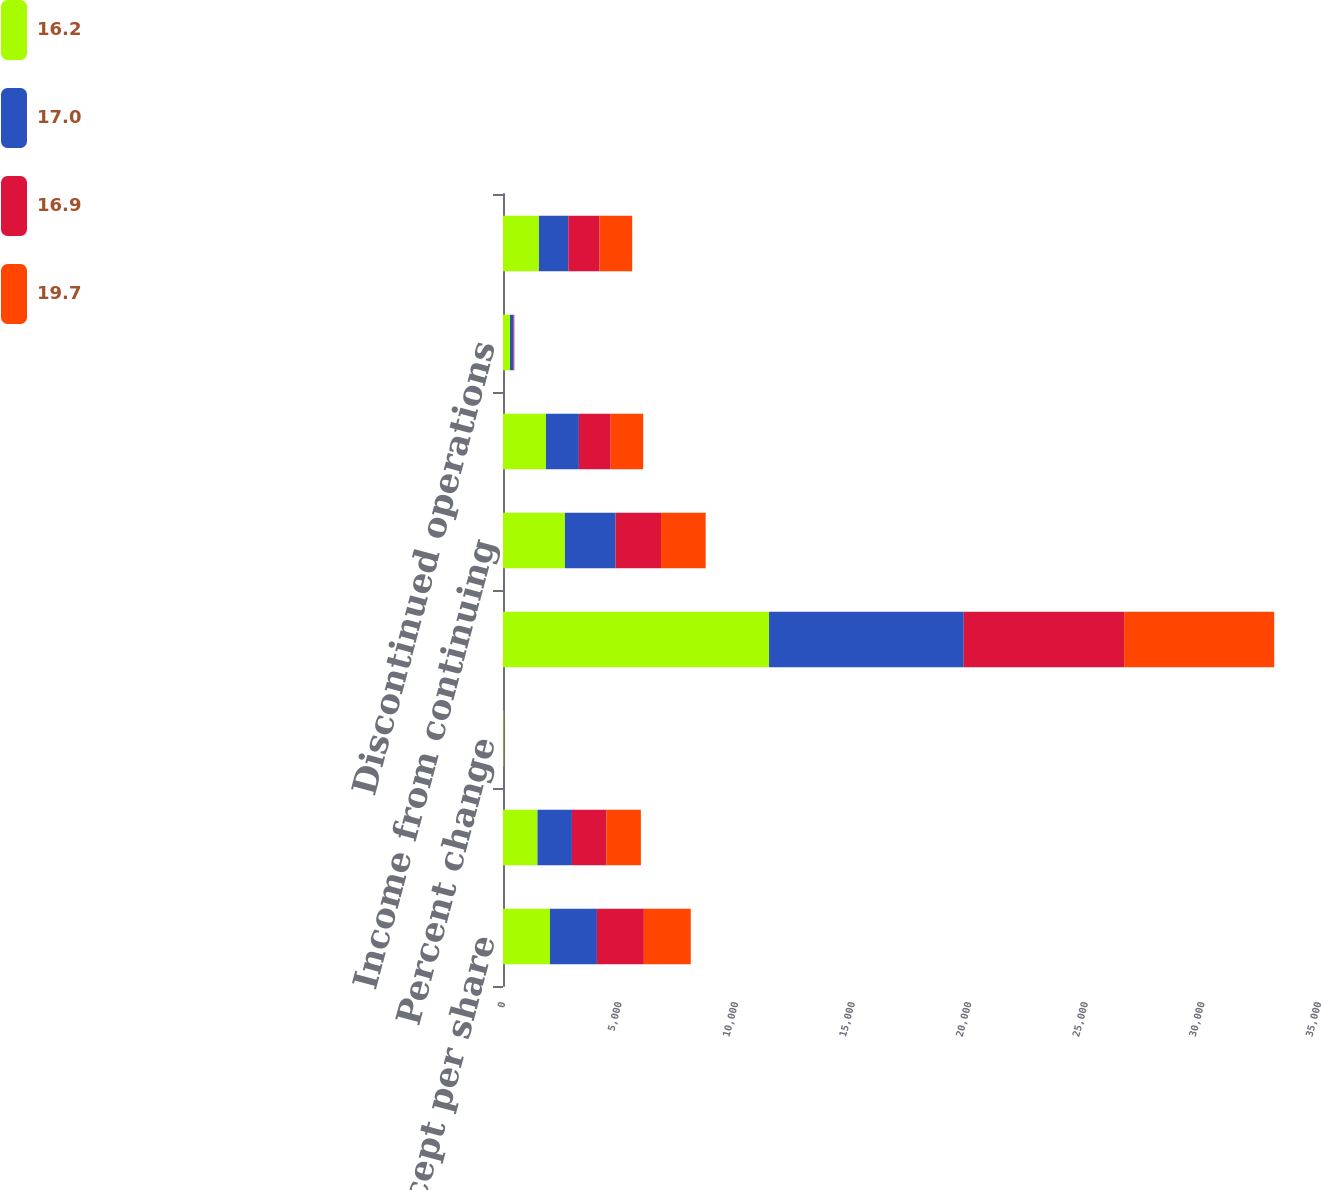<chart> <loc_0><loc_0><loc_500><loc_500><stacked_bar_chart><ecel><fcel>( In millions except per share<fcel>Revenues<fcel>Percent change<fcel>Gross profit<fcel>Income from continuing<fcel>Continuing operations<fcel>Discontinued operations<fcel>Net income<nl><fcel>16.2<fcel>2015<fcel>1478.5<fcel>30.3<fcel>11411<fcel>2657<fcel>1842<fcel>299<fcel>1543<nl><fcel>17<fcel>2014<fcel>1478.5<fcel>12.4<fcel>8352<fcel>2171<fcel>1414<fcel>156<fcel>1258<nl><fcel>16.9<fcel>2013<fcel>1478.5<fcel>0.2<fcel>6881<fcel>1950<fcel>1363<fcel>25<fcel>1338<nl><fcel>19.7<fcel>2012<fcel>1478.5<fcel>9.5<fcel>6435<fcel>1915<fcel>1394<fcel>9<fcel>1403<nl></chart> 